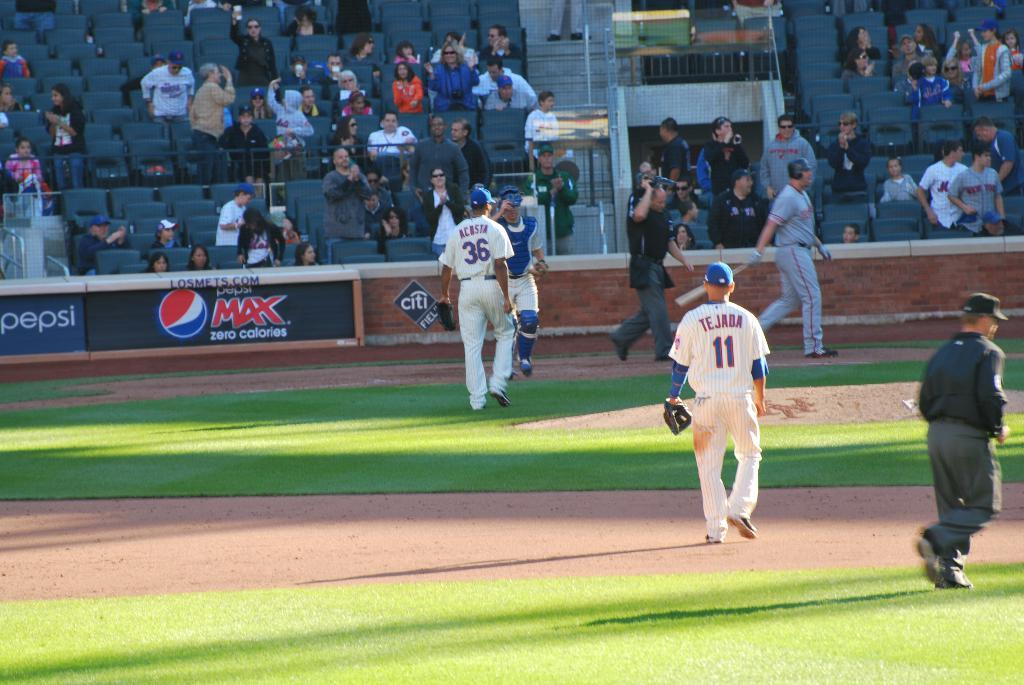<image>
Summarize the visual content of the image. Acosta and the catcher are walking towards each other. 